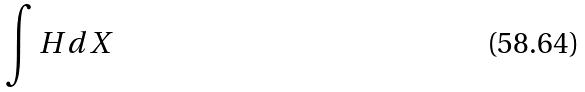<formula> <loc_0><loc_0><loc_500><loc_500>\int H d X</formula> 